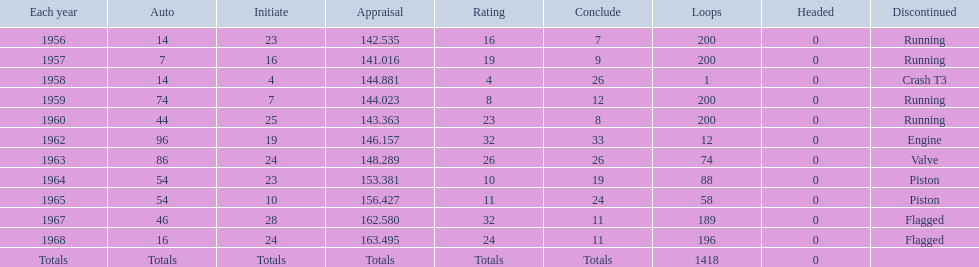What was the last year that it finished the race? 1968. 